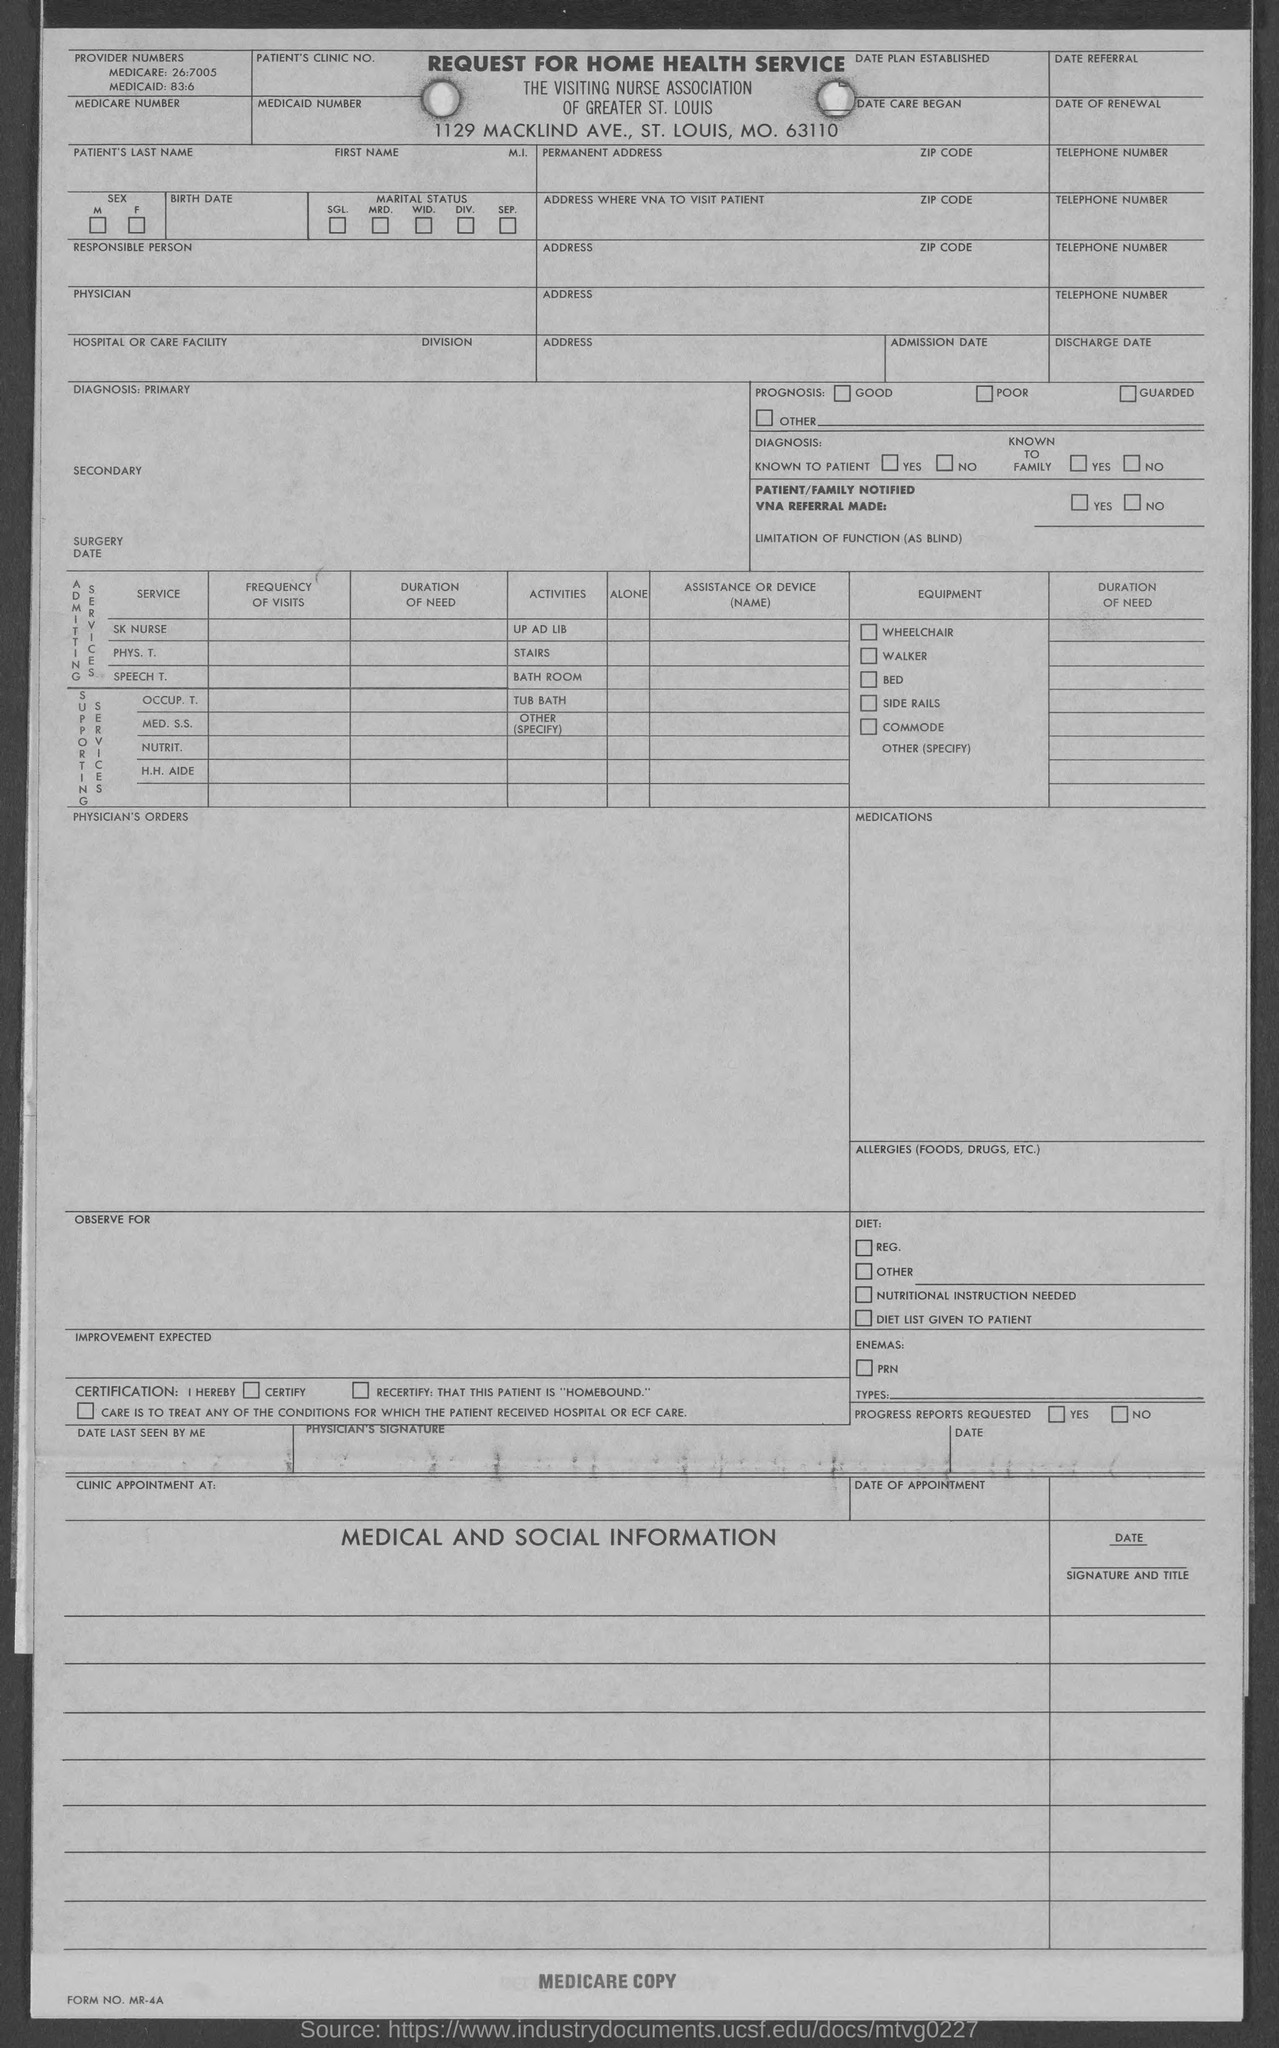Draw attention to some important aspects in this diagram. The Medicaid number is 83:6. The Medicare number is 26:7005. 